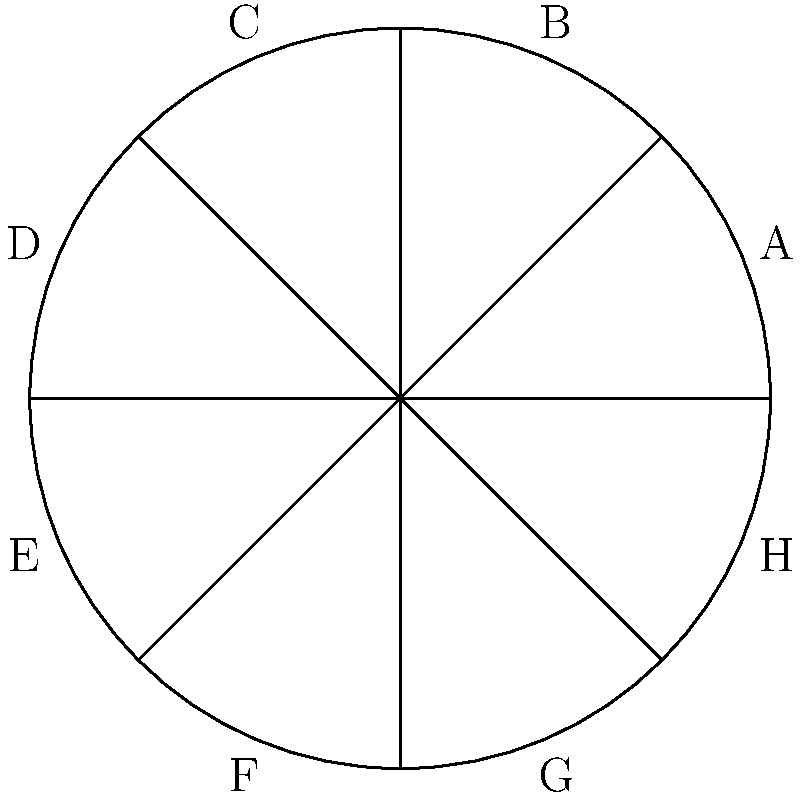In a thought experiment on fair resource distribution, a circular land is divided equally among 8 communities (A through H) as shown in the figure. If community C decides to share its portion equally with communities B and D, what fraction of the total land will community B now possess? To solve this ethical dilemma, let's break it down step-by-step:

1) Initially, the circle is divided into 8 equal parts. Each community owns $\frac{1}{8}$ of the total land.

2) Community C decides to share its portion equally with B and D. This means C's portion will be divided into 3 equal parts.

3) C will keep one part, and give one part each to B and D.

4) The portion that C is giving to B is $\frac{1}{3}$ of C's original share.

5) C's original share was $\frac{1}{8}$ of the total land.

6) Therefore, the additional land B receives is: $\frac{1}{3} \times \frac{1}{8} = \frac{1}{24}$ of the total land.

7) B already had $\frac{1}{8}$ of the land.

8) B's new total is: $\frac{1}{8} + \frac{1}{24} = \frac{3}{24} + \frac{1}{24} = \frac{4}{24} = \frac{1}{6}$

Thus, after C's redistribution, B will possess $\frac{1}{6}$ of the total land.
Answer: $\frac{1}{6}$ 